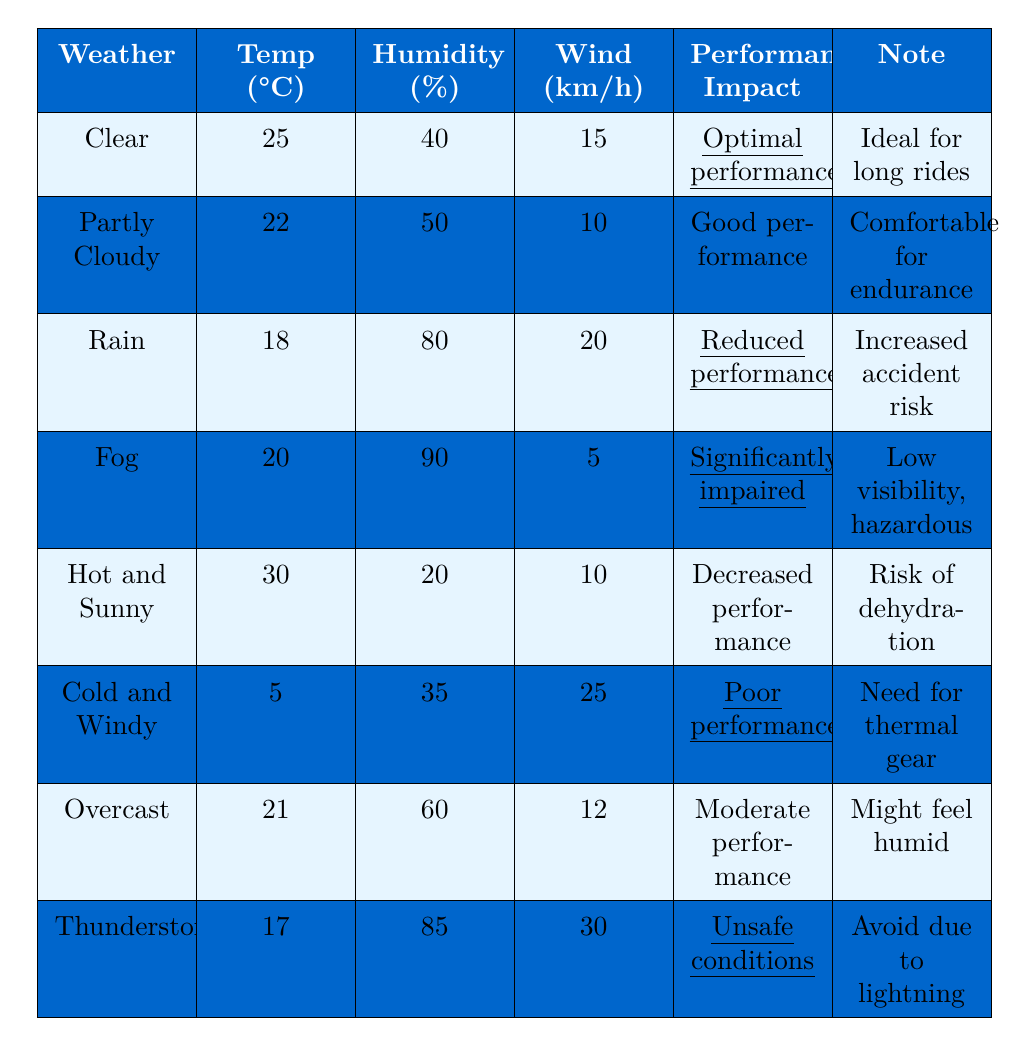What is the performance impact during clear weather conditions? In the table, the performance impact under clear weather conditions is specifically stated as "Optimal performance."
Answer: Optimal performance What is the wind speed in km/h during a thunderstorm? According to the table, the wind speed during a thunderstorm is listed as 30 km/h.
Answer: 30 km/h Which weather condition has the highest humidity percentage? The table indicates that fog has the highest humidity percentage at 90%.
Answer: Fog How does the performance impact in rain compare to performance in fog? The performance impact for rain is "Reduced performance," while for fog it is "Significantly impaired performance." Since "significantly impaired" is worse than "reduced," fog has a more negative impact than rain.
Answer: Fog has a worse impact What is the temperature difference between hot and sunny weather and cold and windy weather? The temperature for hot and sunny weather is 30°C and for cold and windy weather is 5°C. The difference is calculated as 30 - 5 = 25°C.
Answer: 25°C Is cycling safe during thunderstorms according to the table? The table clearly states that during thunderstorms, conditions are classified as "Unsafe conditions," which implies that it is not safe to cycle.
Answer: No What is the average temperature for all weather conditions listed? The temperatures listed are 25, 22, 18, 20, 30, 5, 21, and 17. Adding these gives 25 + 22 + 18 + 20 + 30 + 5 + 21 + 17 = 168. There are 8 conditions, so the average is 168 / 8 = 21°C.
Answer: 21°C Which weather condition has a performance impact of "Poor performance"? In the table, "Poor performance" is the listed performance impact for cold and windy weather.
Answer: Cold and windy What is the hydration risk associated with hot and sunny weather? The note for hot and sunny weather specifies a "Risk of dehydration," indicating that cyclists need to be mindful of hydration during this condition.
Answer: Risk of dehydration How does humidity affect performance in weather conditions? Various conditions show that higher humidity (like 80% in rain and 90% in fog) correlates with reduced performance impacts ("Reduced performance" and "Significantly impaired performance"). Thus, higher humidity typically leads to worse performance.
Answer: Higher humidity leads to worse performance 